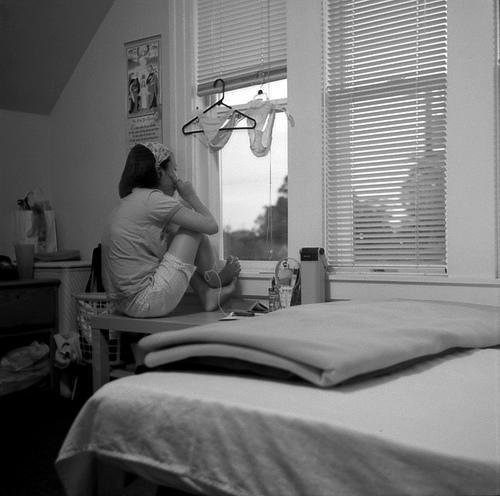How many blinds are open?
Give a very brief answer. 1. How many people are pictured?
Give a very brief answer. 1. 